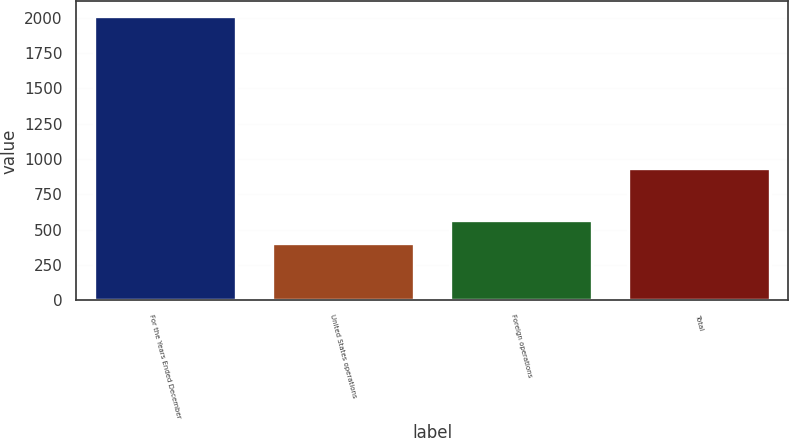Convert chart to OTSL. <chart><loc_0><loc_0><loc_500><loc_500><bar_chart><fcel>For the Years Ended December<fcel>United States operations<fcel>Foreign operations<fcel>Total<nl><fcel>2014<fcel>403.3<fcel>564.37<fcel>939.4<nl></chart> 